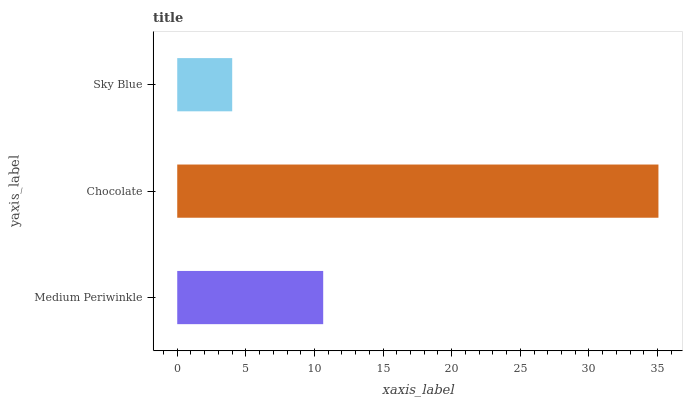Is Sky Blue the minimum?
Answer yes or no. Yes. Is Chocolate the maximum?
Answer yes or no. Yes. Is Chocolate the minimum?
Answer yes or no. No. Is Sky Blue the maximum?
Answer yes or no. No. Is Chocolate greater than Sky Blue?
Answer yes or no. Yes. Is Sky Blue less than Chocolate?
Answer yes or no. Yes. Is Sky Blue greater than Chocolate?
Answer yes or no. No. Is Chocolate less than Sky Blue?
Answer yes or no. No. Is Medium Periwinkle the high median?
Answer yes or no. Yes. Is Medium Periwinkle the low median?
Answer yes or no. Yes. Is Sky Blue the high median?
Answer yes or no. No. Is Sky Blue the low median?
Answer yes or no. No. 